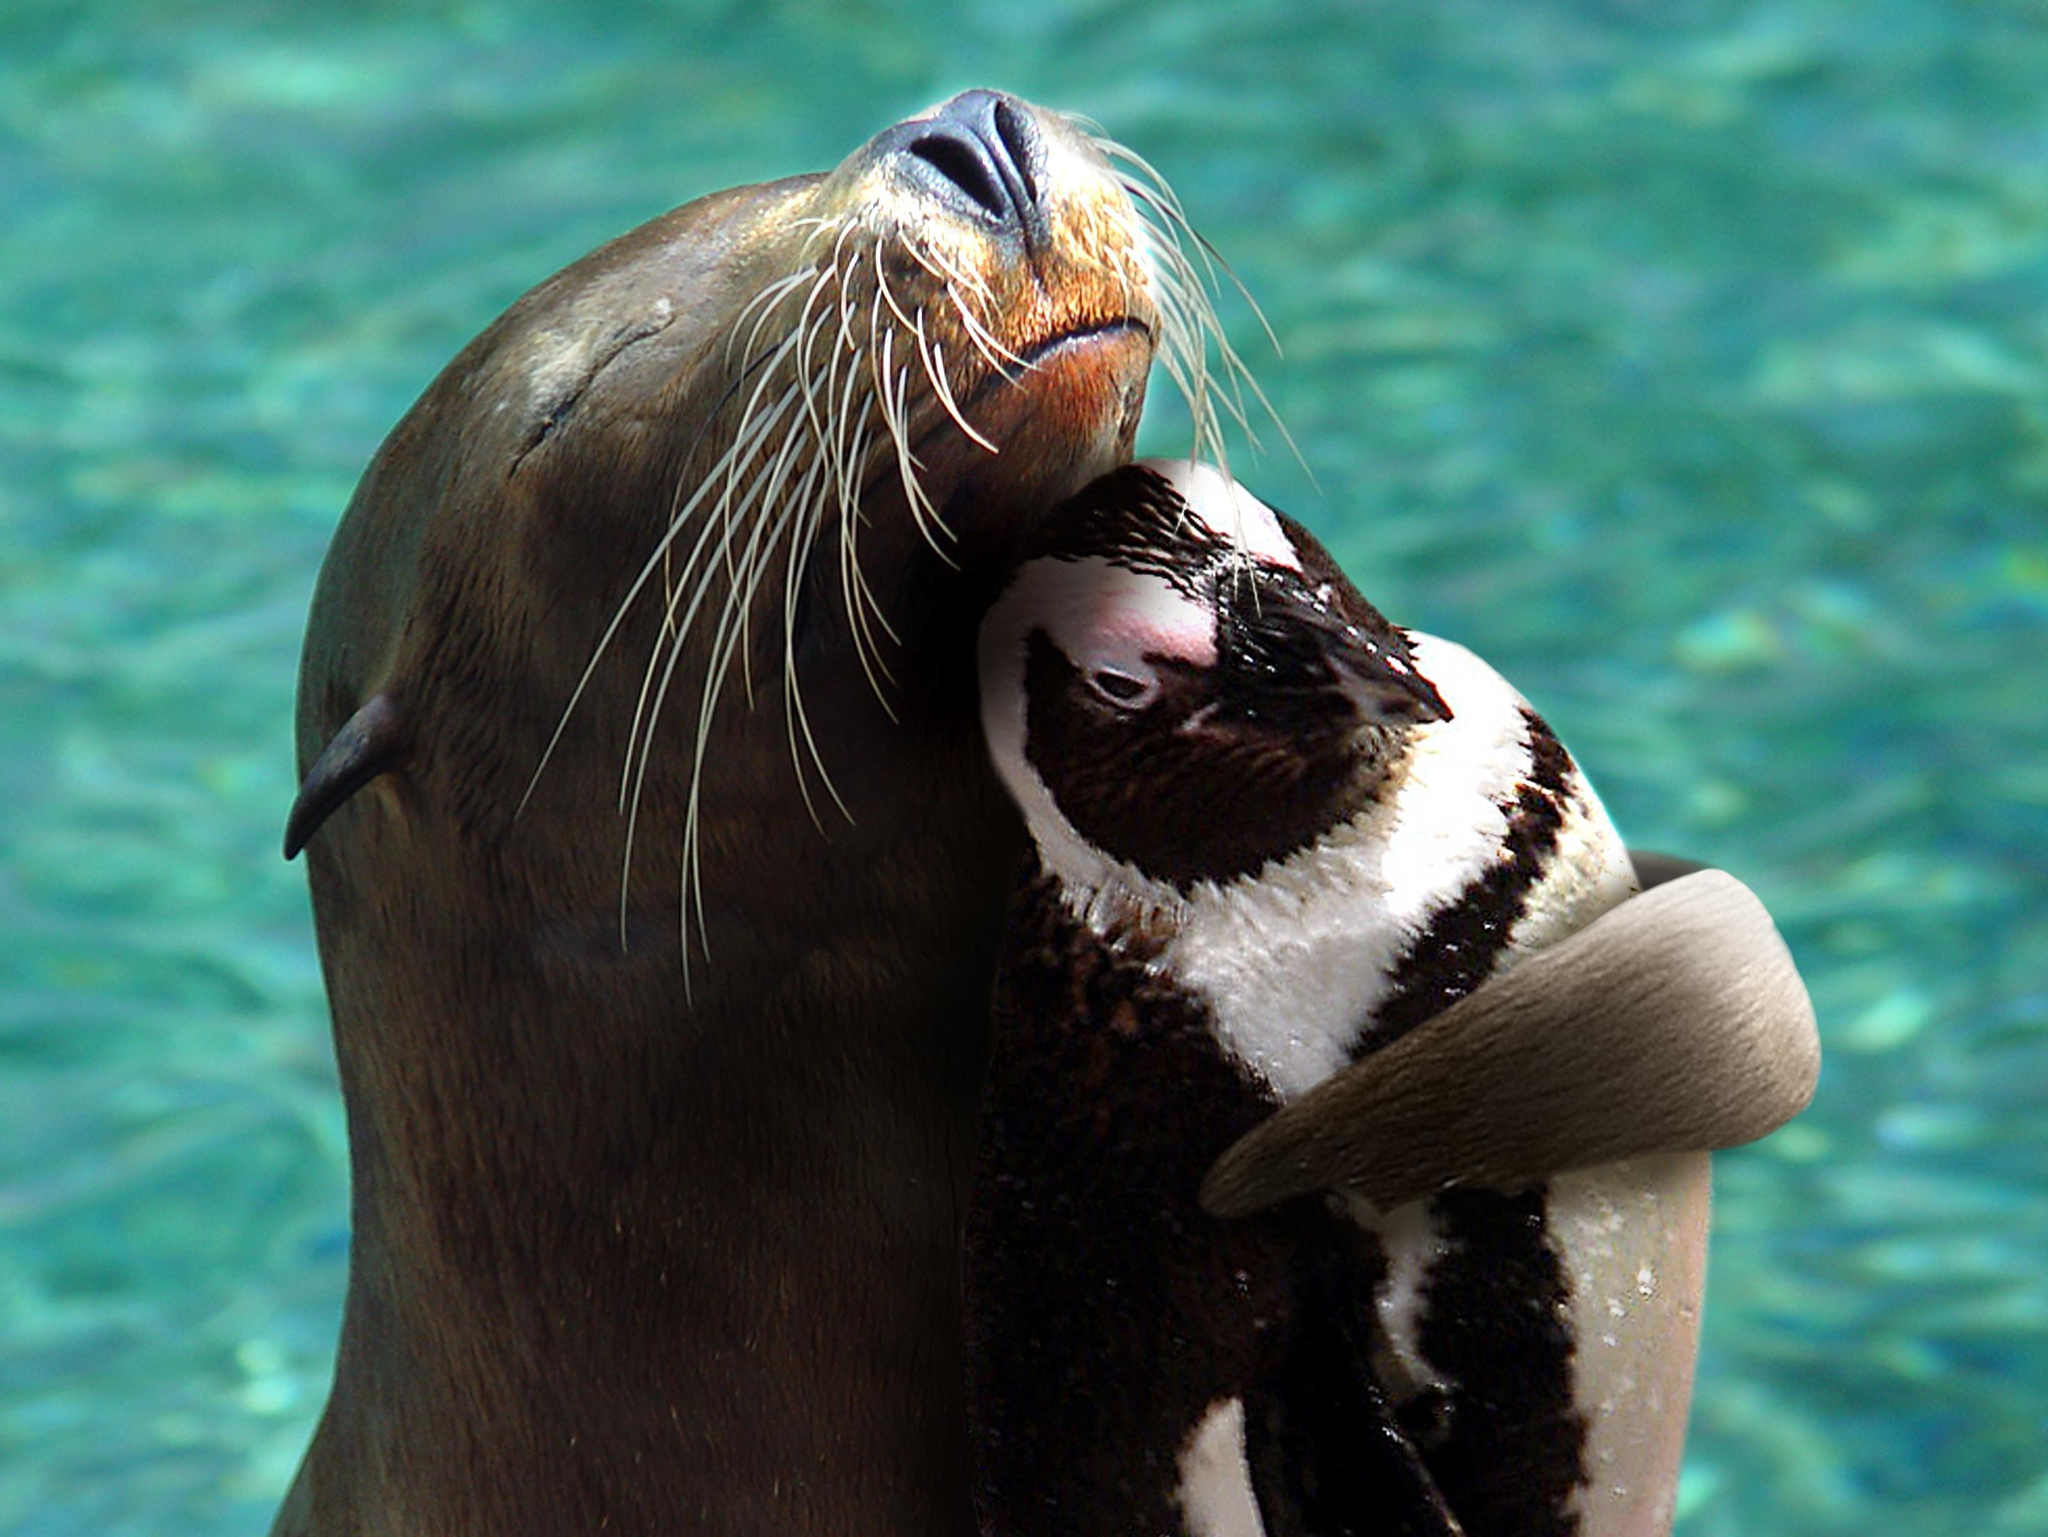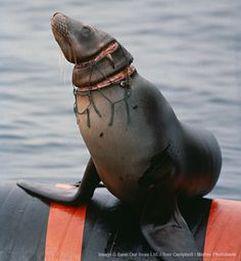The first image is the image on the left, the second image is the image on the right. Analyze the images presented: Is the assertion "The right image shows a seal with a fish held in its mouth." valid? Answer yes or no. No. The first image is the image on the left, the second image is the image on the right. Analyze the images presented: Is the assertion "At least one seal is eating a fish." valid? Answer yes or no. No. 